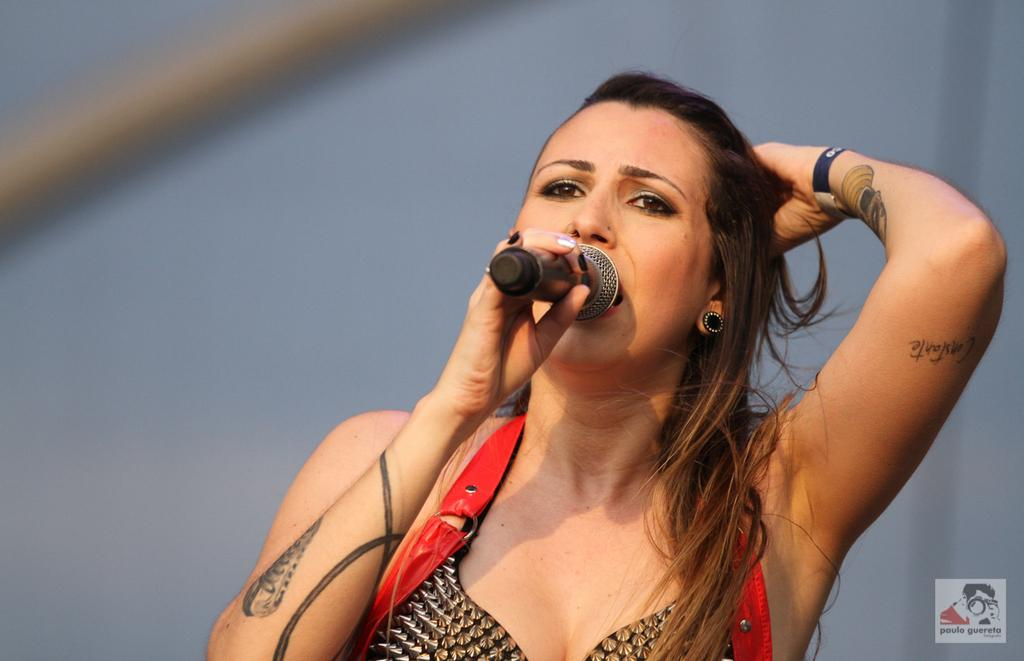Who is the main subject in the image? There is a woman in the image. What is the woman holding in the image? The woman is holding a microphone. What is the woman doing with the microphone? The woman is singing into the microphone. What type of authority does the woman have in the image? There is no indication of the woman's authority in the image; she is simply holding and singing into a microphone. 